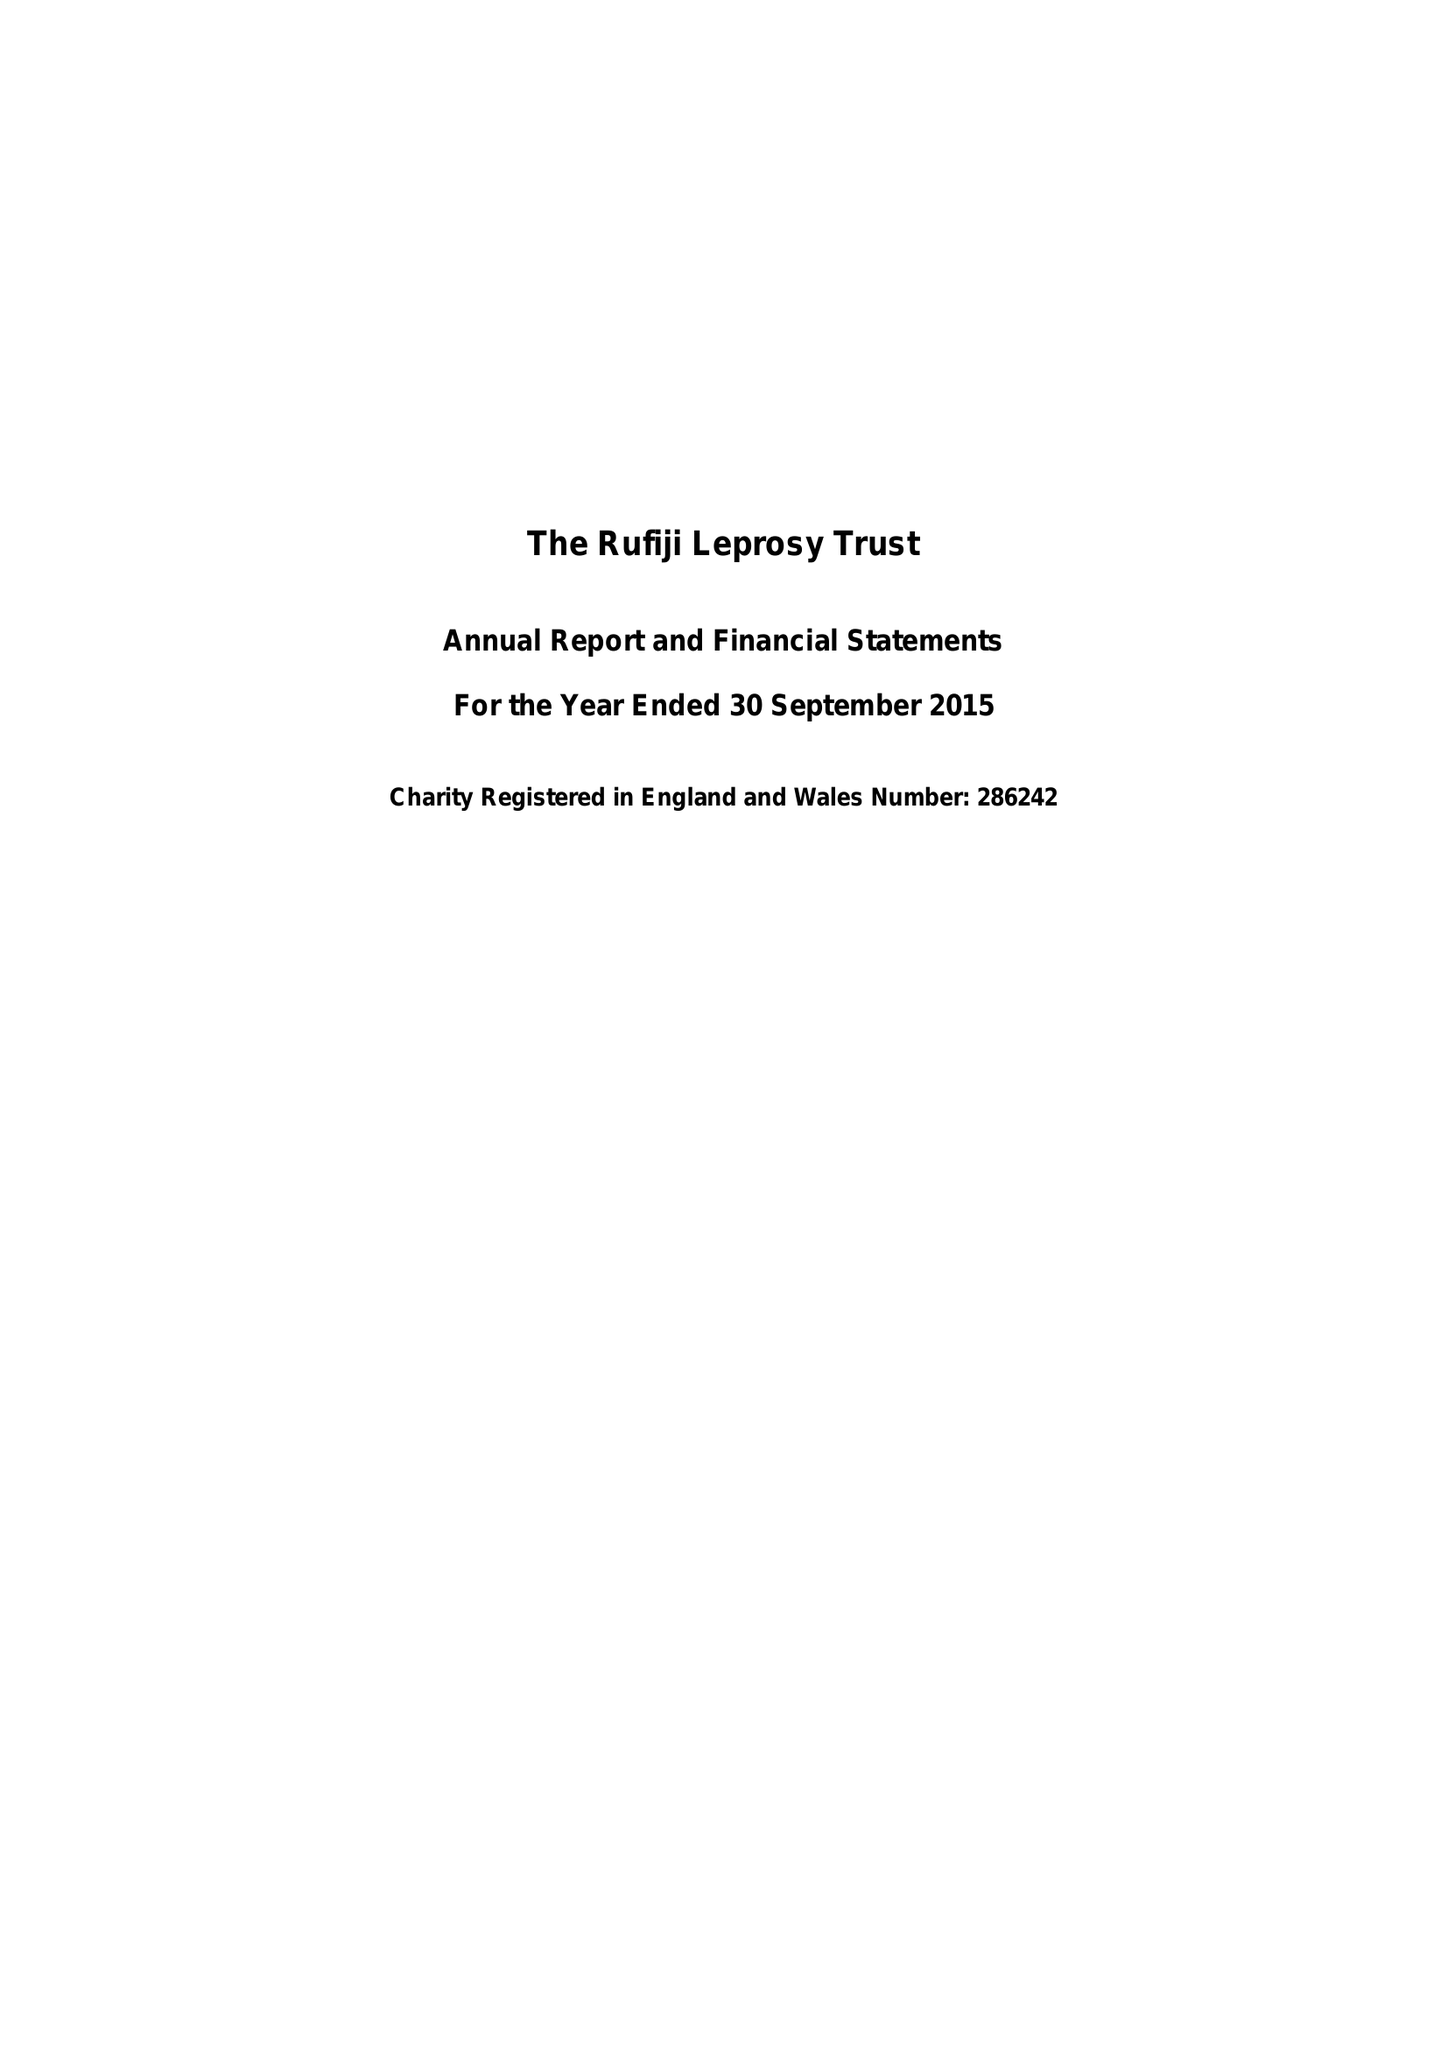What is the value for the report_date?
Answer the question using a single word or phrase. 2015-09-30 